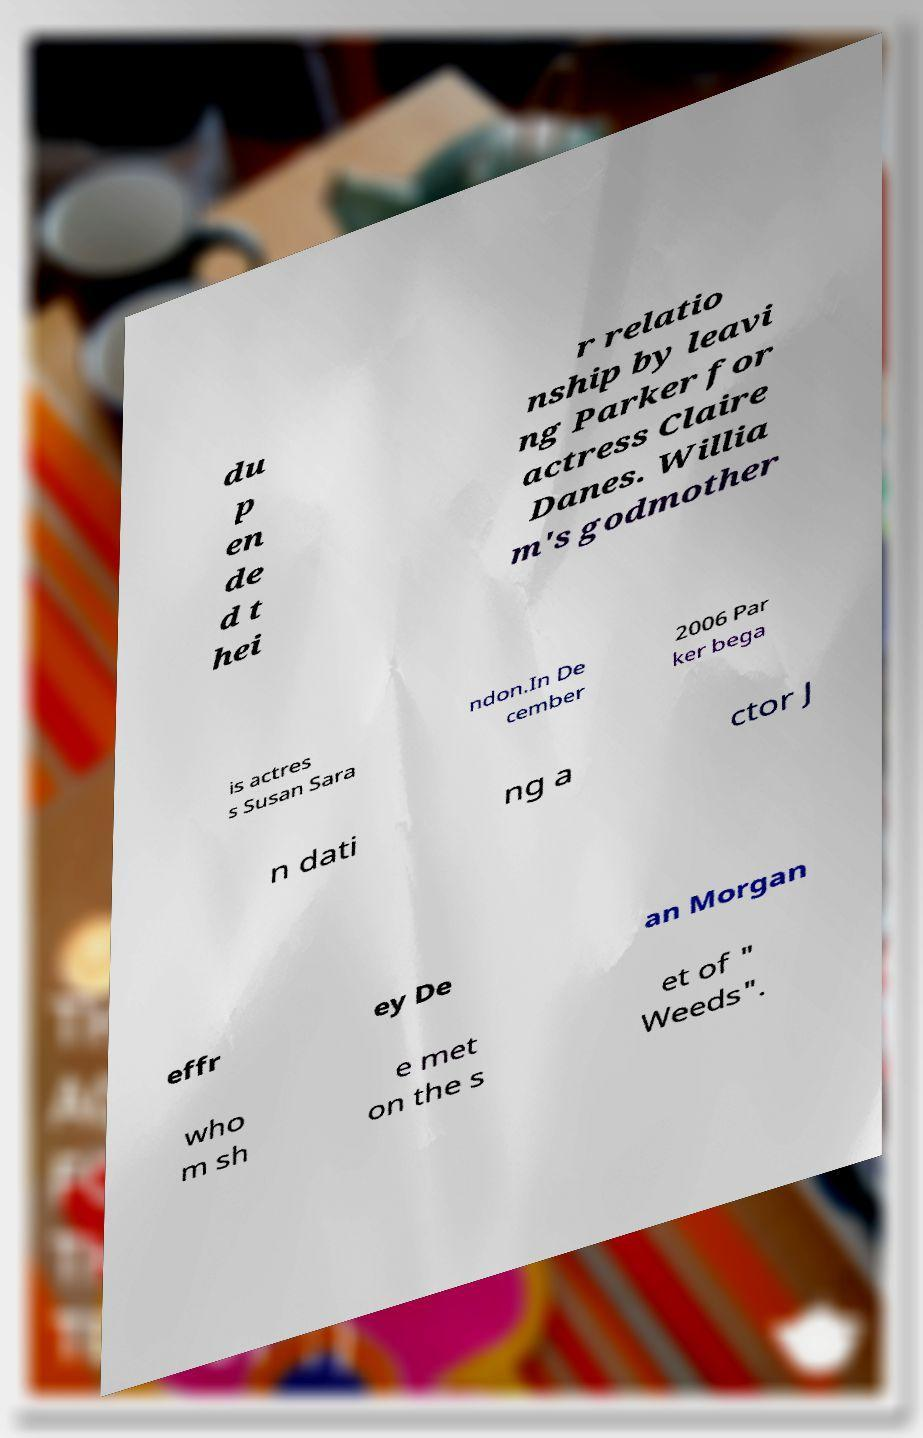I need the written content from this picture converted into text. Can you do that? du p en de d t hei r relatio nship by leavi ng Parker for actress Claire Danes. Willia m's godmother is actres s Susan Sara ndon.In De cember 2006 Par ker bega n dati ng a ctor J effr ey De an Morgan who m sh e met on the s et of " Weeds". 